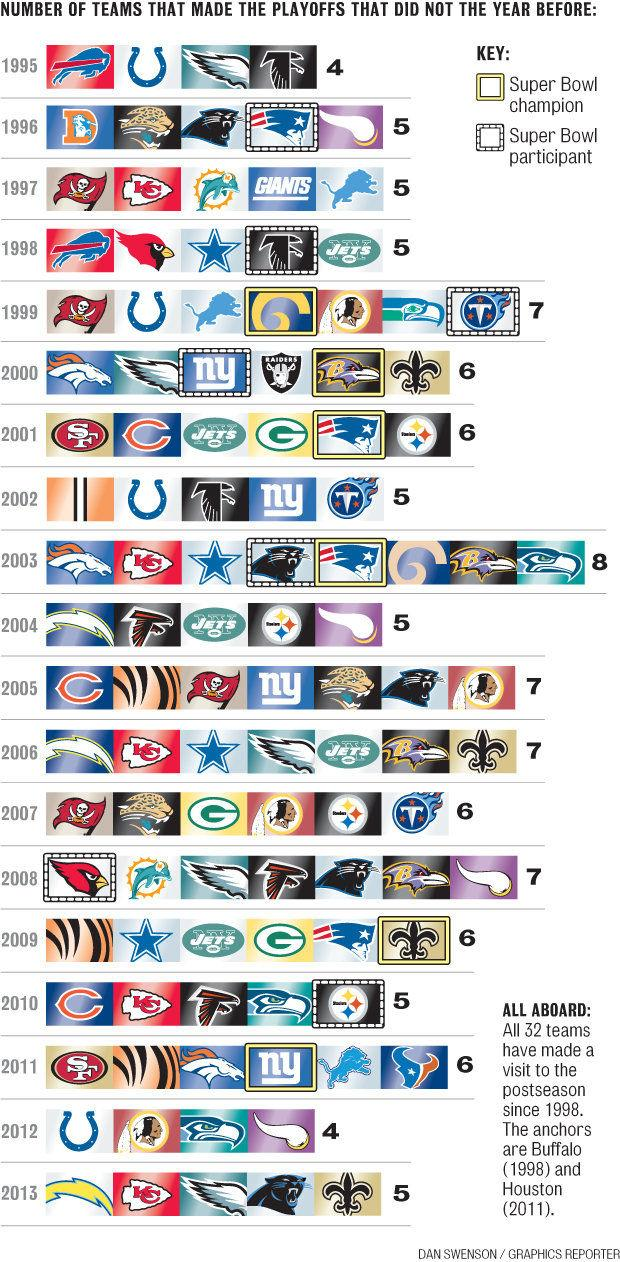Outline some significant characteristics in this image. In 2011, six NFL teams that did not qualify for the playoffs the previous year made it to the postseason. There are 32 teams in the National Football League (NFL). In 1997, five NFL teams that did not qualify for the playoffs the previous year were able to secure a spot in the postseason. 